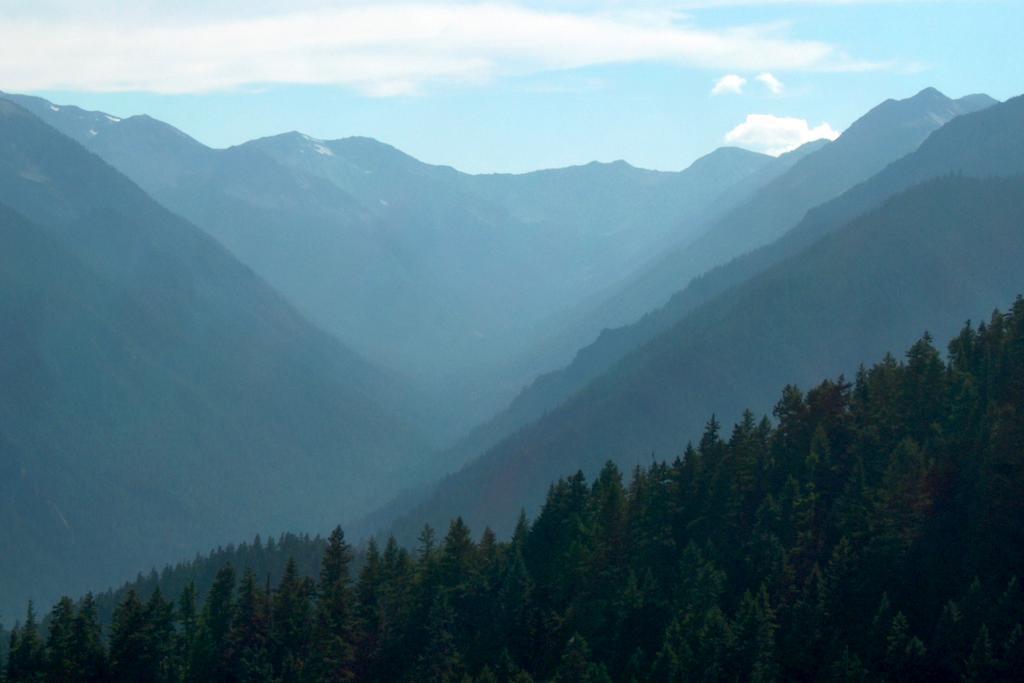Can you describe this image briefly? In the background we can see the sky and clouds. In this picture we can see the hills. At the bottom portion of the picture we can see the trees. 